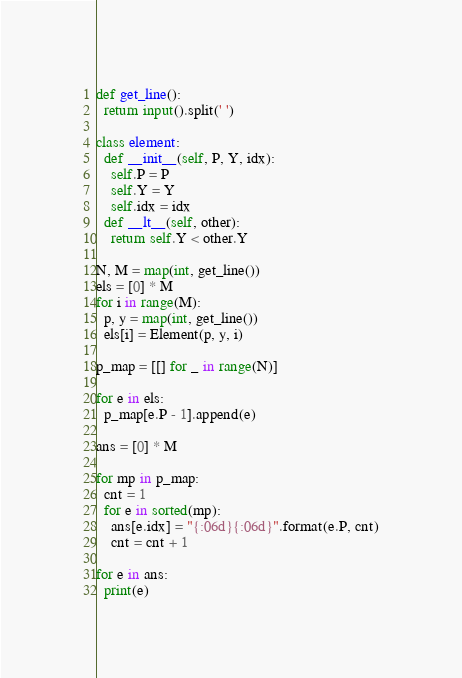Convert code to text. <code><loc_0><loc_0><loc_500><loc_500><_Python_>def get_line():
  return input().split(' ')

class element:
  def __init__(self, P, Y, idx):
    self.P = P
    self.Y = Y
    self.idx = idx
  def __lt__(self, other):
    return self.Y < other.Y

N, M = map(int, get_line())
els = [0] * M
for i in range(M):
  p, y = map(int, get_line())
  els[i] = Element(p, y, i)

p_map = [[] for _ in range(N)]

for e in els:
  p_map[e.P - 1].append(e)

ans = [0] * M

for mp in p_map:
  cnt = 1
  for e in sorted(mp):
    ans[e.idx] = "{:06d}{:06d}".format(e.P, cnt)
    cnt = cnt + 1

for e in ans:
  print(e)
</code> 